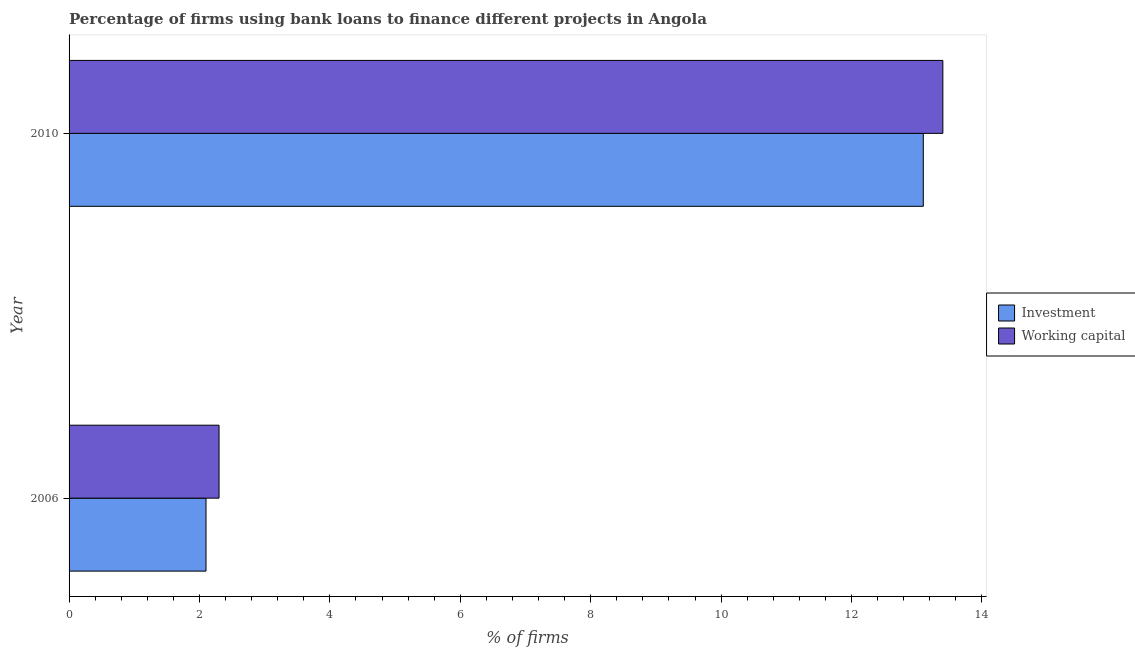How many groups of bars are there?
Provide a short and direct response. 2. Are the number of bars on each tick of the Y-axis equal?
Offer a terse response. Yes. How many bars are there on the 1st tick from the top?
Your response must be concise. 2. How many bars are there on the 2nd tick from the bottom?
Offer a terse response. 2. What is the label of the 1st group of bars from the top?
Your response must be concise. 2010. In how many cases, is the number of bars for a given year not equal to the number of legend labels?
Offer a very short reply. 0. What is the percentage of firms using banks to finance investment in 2010?
Offer a very short reply. 13.1. Across all years, what is the maximum percentage of firms using banks to finance investment?
Offer a terse response. 13.1. Across all years, what is the minimum percentage of firms using banks to finance investment?
Your response must be concise. 2.1. In which year was the percentage of firms using banks to finance investment maximum?
Provide a short and direct response. 2010. In which year was the percentage of firms using banks to finance working capital minimum?
Provide a succinct answer. 2006. What is the difference between the percentage of firms using banks to finance investment in 2006 and that in 2010?
Your answer should be compact. -11. In how many years, is the percentage of firms using banks to finance investment greater than 12 %?
Provide a succinct answer. 1. What is the ratio of the percentage of firms using banks to finance working capital in 2006 to that in 2010?
Provide a succinct answer. 0.17. Is the percentage of firms using banks to finance investment in 2006 less than that in 2010?
Provide a succinct answer. Yes. Is the difference between the percentage of firms using banks to finance investment in 2006 and 2010 greater than the difference between the percentage of firms using banks to finance working capital in 2006 and 2010?
Ensure brevity in your answer.  Yes. In how many years, is the percentage of firms using banks to finance working capital greater than the average percentage of firms using banks to finance working capital taken over all years?
Ensure brevity in your answer.  1. What does the 1st bar from the top in 2006 represents?
Keep it short and to the point. Working capital. What does the 1st bar from the bottom in 2006 represents?
Provide a short and direct response. Investment. Are all the bars in the graph horizontal?
Provide a succinct answer. Yes. How many years are there in the graph?
Offer a very short reply. 2. What is the difference between two consecutive major ticks on the X-axis?
Give a very brief answer. 2. Are the values on the major ticks of X-axis written in scientific E-notation?
Your response must be concise. No. Does the graph contain any zero values?
Your response must be concise. No. Does the graph contain grids?
Give a very brief answer. No. How are the legend labels stacked?
Ensure brevity in your answer.  Vertical. What is the title of the graph?
Keep it short and to the point. Percentage of firms using bank loans to finance different projects in Angola. Does "Time to export" appear as one of the legend labels in the graph?
Keep it short and to the point. No. What is the label or title of the X-axis?
Provide a short and direct response. % of firms. What is the % of firms in Investment in 2010?
Make the answer very short. 13.1. Across all years, what is the maximum % of firms in Working capital?
Your answer should be compact. 13.4. Across all years, what is the minimum % of firms in Investment?
Your answer should be compact. 2.1. Across all years, what is the minimum % of firms in Working capital?
Provide a short and direct response. 2.3. What is the total % of firms of Working capital in the graph?
Offer a terse response. 15.7. What is the difference between the % of firms of Investment in 2006 and that in 2010?
Give a very brief answer. -11. What is the difference between the % of firms in Investment in 2006 and the % of firms in Working capital in 2010?
Give a very brief answer. -11.3. What is the average % of firms in Investment per year?
Make the answer very short. 7.6. What is the average % of firms in Working capital per year?
Provide a succinct answer. 7.85. In the year 2006, what is the difference between the % of firms in Investment and % of firms in Working capital?
Give a very brief answer. -0.2. What is the ratio of the % of firms of Investment in 2006 to that in 2010?
Keep it short and to the point. 0.16. What is the ratio of the % of firms in Working capital in 2006 to that in 2010?
Your answer should be compact. 0.17. What is the difference between the highest and the lowest % of firms in Working capital?
Your answer should be very brief. 11.1. 